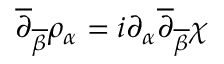<formula> <loc_0><loc_0><loc_500><loc_500>\overline { \partial } _ { \overline { \beta } } \rho _ { \alpha } = i \partial _ { \alpha } \overline { \partial } _ { \overline { \beta } } \chi</formula> 